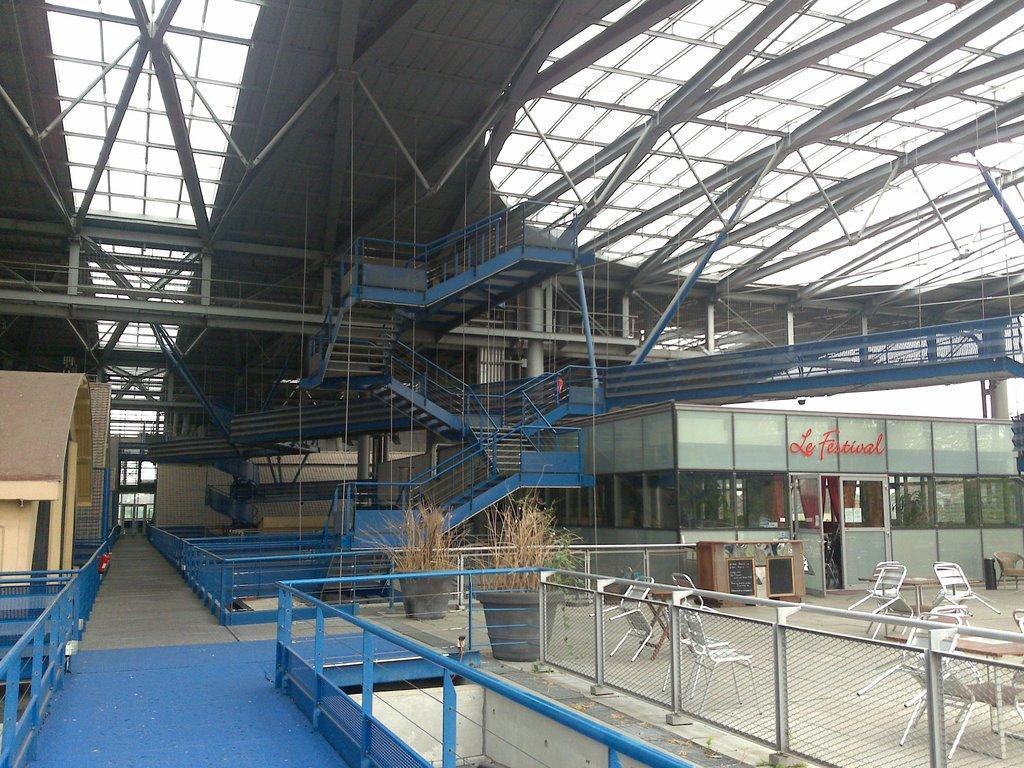In one or two sentences, can you explain what this image depicts? These are stairs and shed, these are chairs, these are plants. 